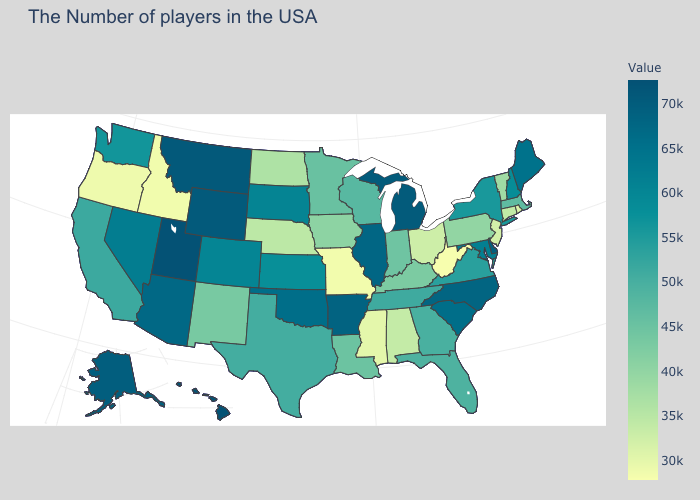Does Georgia have a lower value than Maine?
Concise answer only. Yes. Among the states that border New Mexico , which have the lowest value?
Give a very brief answer. Texas. Does Kansas have a higher value than Wisconsin?
Keep it brief. Yes. Does Hawaii have the highest value in the USA?
Concise answer only. Yes. Is the legend a continuous bar?
Write a very short answer. Yes. Which states have the highest value in the USA?
Quick response, please. Hawaii. Does Nebraska have the lowest value in the USA?
Write a very short answer. No. 